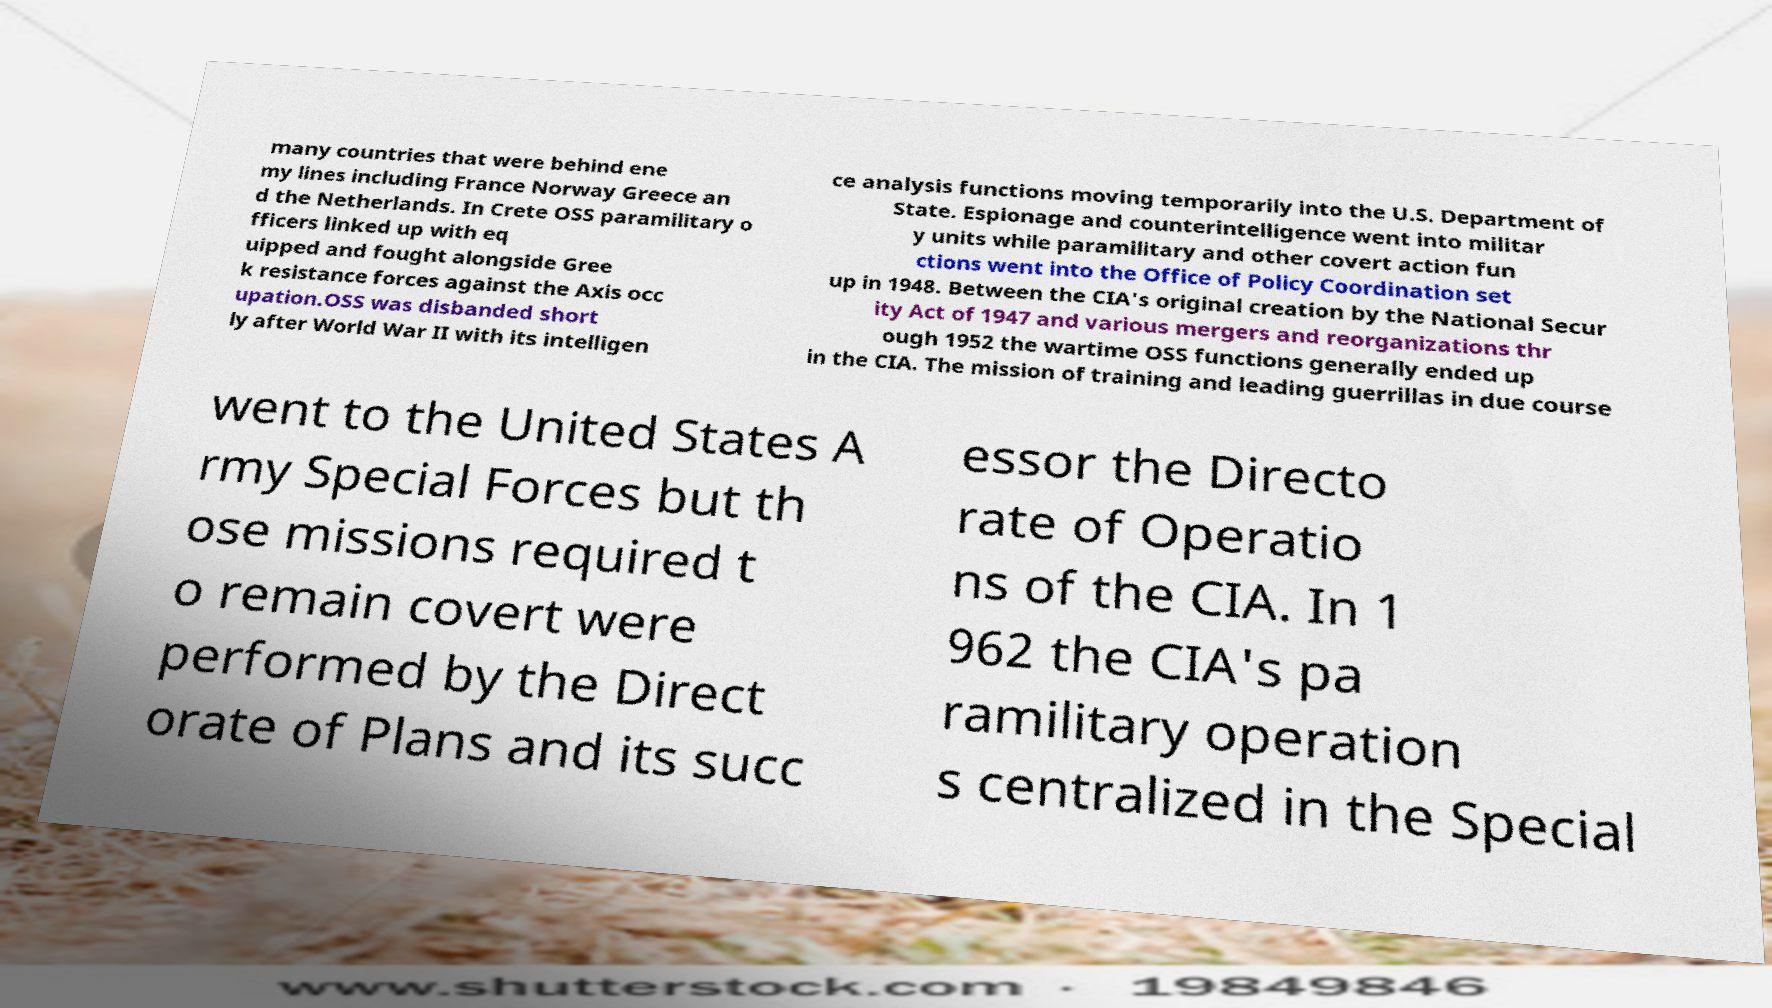Please identify and transcribe the text found in this image. many countries that were behind ene my lines including France Norway Greece an d the Netherlands. In Crete OSS paramilitary o fficers linked up with eq uipped and fought alongside Gree k resistance forces against the Axis occ upation.OSS was disbanded short ly after World War II with its intelligen ce analysis functions moving temporarily into the U.S. Department of State. Espionage and counterintelligence went into militar y units while paramilitary and other covert action fun ctions went into the Office of Policy Coordination set up in 1948. Between the CIA's original creation by the National Secur ity Act of 1947 and various mergers and reorganizations thr ough 1952 the wartime OSS functions generally ended up in the CIA. The mission of training and leading guerrillas in due course went to the United States A rmy Special Forces but th ose missions required t o remain covert were performed by the Direct orate of Plans and its succ essor the Directo rate of Operatio ns of the CIA. In 1 962 the CIA's pa ramilitary operation s centralized in the Special 